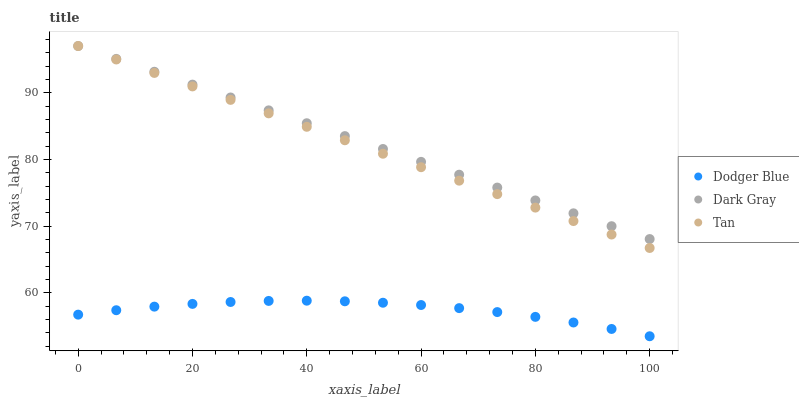Does Dodger Blue have the minimum area under the curve?
Answer yes or no. Yes. Does Dark Gray have the maximum area under the curve?
Answer yes or no. Yes. Does Tan have the minimum area under the curve?
Answer yes or no. No. Does Tan have the maximum area under the curve?
Answer yes or no. No. Is Dark Gray the smoothest?
Answer yes or no. Yes. Is Dodger Blue the roughest?
Answer yes or no. Yes. Is Tan the smoothest?
Answer yes or no. No. Is Tan the roughest?
Answer yes or no. No. Does Dodger Blue have the lowest value?
Answer yes or no. Yes. Does Tan have the lowest value?
Answer yes or no. No. Does Tan have the highest value?
Answer yes or no. Yes. Does Dodger Blue have the highest value?
Answer yes or no. No. Is Dodger Blue less than Dark Gray?
Answer yes or no. Yes. Is Dark Gray greater than Dodger Blue?
Answer yes or no. Yes. Does Dark Gray intersect Tan?
Answer yes or no. Yes. Is Dark Gray less than Tan?
Answer yes or no. No. Is Dark Gray greater than Tan?
Answer yes or no. No. Does Dodger Blue intersect Dark Gray?
Answer yes or no. No. 